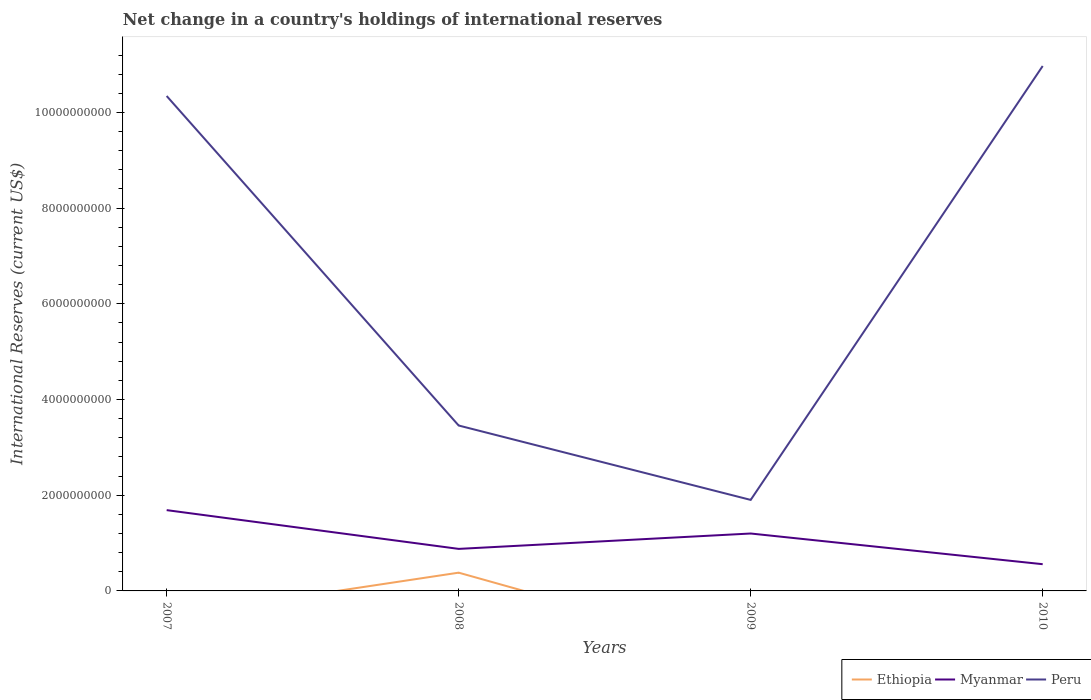Is the number of lines equal to the number of legend labels?
Give a very brief answer. No. Across all years, what is the maximum international reserves in Ethiopia?
Offer a terse response. 0. What is the total international reserves in Peru in the graph?
Make the answer very short. 6.89e+09. What is the difference between the highest and the second highest international reserves in Ethiopia?
Keep it short and to the point. 3.82e+08. What is the difference between the highest and the lowest international reserves in Myanmar?
Give a very brief answer. 2. Is the international reserves in Myanmar strictly greater than the international reserves in Peru over the years?
Give a very brief answer. Yes. How many lines are there?
Your response must be concise. 3. How many years are there in the graph?
Provide a succinct answer. 4. Are the values on the major ticks of Y-axis written in scientific E-notation?
Offer a very short reply. No. Does the graph contain any zero values?
Provide a short and direct response. Yes. Does the graph contain grids?
Make the answer very short. No. Where does the legend appear in the graph?
Your response must be concise. Bottom right. How many legend labels are there?
Offer a terse response. 3. What is the title of the graph?
Your answer should be compact. Net change in a country's holdings of international reserves. What is the label or title of the Y-axis?
Provide a short and direct response. International Reserves (current US$). What is the International Reserves (current US$) of Ethiopia in 2007?
Offer a terse response. 0. What is the International Reserves (current US$) of Myanmar in 2007?
Provide a succinct answer. 1.69e+09. What is the International Reserves (current US$) of Peru in 2007?
Give a very brief answer. 1.03e+1. What is the International Reserves (current US$) of Ethiopia in 2008?
Give a very brief answer. 3.82e+08. What is the International Reserves (current US$) in Myanmar in 2008?
Provide a succinct answer. 8.78e+08. What is the International Reserves (current US$) of Peru in 2008?
Provide a succinct answer. 3.46e+09. What is the International Reserves (current US$) in Ethiopia in 2009?
Provide a short and direct response. 0. What is the International Reserves (current US$) in Myanmar in 2009?
Ensure brevity in your answer.  1.20e+09. What is the International Reserves (current US$) of Peru in 2009?
Give a very brief answer. 1.90e+09. What is the International Reserves (current US$) of Ethiopia in 2010?
Your answer should be compact. 0. What is the International Reserves (current US$) in Myanmar in 2010?
Make the answer very short. 5.59e+08. What is the International Reserves (current US$) of Peru in 2010?
Make the answer very short. 1.10e+1. Across all years, what is the maximum International Reserves (current US$) in Ethiopia?
Your response must be concise. 3.82e+08. Across all years, what is the maximum International Reserves (current US$) of Myanmar?
Offer a terse response. 1.69e+09. Across all years, what is the maximum International Reserves (current US$) of Peru?
Make the answer very short. 1.10e+1. Across all years, what is the minimum International Reserves (current US$) of Myanmar?
Ensure brevity in your answer.  5.59e+08. Across all years, what is the minimum International Reserves (current US$) of Peru?
Offer a terse response. 1.90e+09. What is the total International Reserves (current US$) of Ethiopia in the graph?
Offer a terse response. 3.82e+08. What is the total International Reserves (current US$) of Myanmar in the graph?
Offer a very short reply. 4.33e+09. What is the total International Reserves (current US$) in Peru in the graph?
Your answer should be very brief. 2.67e+1. What is the difference between the International Reserves (current US$) in Myanmar in 2007 and that in 2008?
Make the answer very short. 8.10e+08. What is the difference between the International Reserves (current US$) in Peru in 2007 and that in 2008?
Offer a terse response. 6.89e+09. What is the difference between the International Reserves (current US$) in Myanmar in 2007 and that in 2009?
Ensure brevity in your answer.  4.88e+08. What is the difference between the International Reserves (current US$) of Peru in 2007 and that in 2009?
Your answer should be very brief. 8.44e+09. What is the difference between the International Reserves (current US$) of Myanmar in 2007 and that in 2010?
Make the answer very short. 1.13e+09. What is the difference between the International Reserves (current US$) of Peru in 2007 and that in 2010?
Your answer should be very brief. -6.27e+08. What is the difference between the International Reserves (current US$) in Myanmar in 2008 and that in 2009?
Your answer should be very brief. -3.21e+08. What is the difference between the International Reserves (current US$) in Peru in 2008 and that in 2009?
Provide a short and direct response. 1.55e+09. What is the difference between the International Reserves (current US$) in Myanmar in 2008 and that in 2010?
Make the answer very short. 3.20e+08. What is the difference between the International Reserves (current US$) of Peru in 2008 and that in 2010?
Your response must be concise. -7.51e+09. What is the difference between the International Reserves (current US$) of Myanmar in 2009 and that in 2010?
Offer a very short reply. 6.41e+08. What is the difference between the International Reserves (current US$) of Peru in 2009 and that in 2010?
Make the answer very short. -9.07e+09. What is the difference between the International Reserves (current US$) of Myanmar in 2007 and the International Reserves (current US$) of Peru in 2008?
Offer a very short reply. -1.77e+09. What is the difference between the International Reserves (current US$) of Myanmar in 2007 and the International Reserves (current US$) of Peru in 2009?
Your answer should be very brief. -2.14e+08. What is the difference between the International Reserves (current US$) of Myanmar in 2007 and the International Reserves (current US$) of Peru in 2010?
Keep it short and to the point. -9.28e+09. What is the difference between the International Reserves (current US$) of Ethiopia in 2008 and the International Reserves (current US$) of Myanmar in 2009?
Keep it short and to the point. -8.18e+08. What is the difference between the International Reserves (current US$) of Ethiopia in 2008 and the International Reserves (current US$) of Peru in 2009?
Your answer should be very brief. -1.52e+09. What is the difference between the International Reserves (current US$) of Myanmar in 2008 and the International Reserves (current US$) of Peru in 2009?
Give a very brief answer. -1.02e+09. What is the difference between the International Reserves (current US$) in Ethiopia in 2008 and the International Reserves (current US$) in Myanmar in 2010?
Provide a succinct answer. -1.77e+08. What is the difference between the International Reserves (current US$) of Ethiopia in 2008 and the International Reserves (current US$) of Peru in 2010?
Your answer should be compact. -1.06e+1. What is the difference between the International Reserves (current US$) in Myanmar in 2008 and the International Reserves (current US$) in Peru in 2010?
Your answer should be compact. -1.01e+1. What is the difference between the International Reserves (current US$) in Myanmar in 2009 and the International Reserves (current US$) in Peru in 2010?
Your response must be concise. -9.77e+09. What is the average International Reserves (current US$) of Ethiopia per year?
Offer a terse response. 9.54e+07. What is the average International Reserves (current US$) in Myanmar per year?
Give a very brief answer. 1.08e+09. What is the average International Reserves (current US$) of Peru per year?
Your response must be concise. 6.67e+09. In the year 2007, what is the difference between the International Reserves (current US$) of Myanmar and International Reserves (current US$) of Peru?
Give a very brief answer. -8.66e+09. In the year 2008, what is the difference between the International Reserves (current US$) in Ethiopia and International Reserves (current US$) in Myanmar?
Offer a terse response. -4.97e+08. In the year 2008, what is the difference between the International Reserves (current US$) of Ethiopia and International Reserves (current US$) of Peru?
Your answer should be compact. -3.08e+09. In the year 2008, what is the difference between the International Reserves (current US$) in Myanmar and International Reserves (current US$) in Peru?
Your response must be concise. -2.58e+09. In the year 2009, what is the difference between the International Reserves (current US$) of Myanmar and International Reserves (current US$) of Peru?
Offer a very short reply. -7.02e+08. In the year 2010, what is the difference between the International Reserves (current US$) in Myanmar and International Reserves (current US$) in Peru?
Your answer should be very brief. -1.04e+1. What is the ratio of the International Reserves (current US$) in Myanmar in 2007 to that in 2008?
Ensure brevity in your answer.  1.92. What is the ratio of the International Reserves (current US$) of Peru in 2007 to that in 2008?
Your response must be concise. 2.99. What is the ratio of the International Reserves (current US$) of Myanmar in 2007 to that in 2009?
Offer a terse response. 1.41. What is the ratio of the International Reserves (current US$) of Peru in 2007 to that in 2009?
Ensure brevity in your answer.  5.44. What is the ratio of the International Reserves (current US$) of Myanmar in 2007 to that in 2010?
Make the answer very short. 3.02. What is the ratio of the International Reserves (current US$) in Peru in 2007 to that in 2010?
Offer a terse response. 0.94. What is the ratio of the International Reserves (current US$) in Myanmar in 2008 to that in 2009?
Provide a succinct answer. 0.73. What is the ratio of the International Reserves (current US$) in Peru in 2008 to that in 2009?
Ensure brevity in your answer.  1.82. What is the ratio of the International Reserves (current US$) of Myanmar in 2008 to that in 2010?
Provide a short and direct response. 1.57. What is the ratio of the International Reserves (current US$) in Peru in 2008 to that in 2010?
Your answer should be compact. 0.32. What is the ratio of the International Reserves (current US$) in Myanmar in 2009 to that in 2010?
Your response must be concise. 2.15. What is the ratio of the International Reserves (current US$) of Peru in 2009 to that in 2010?
Offer a very short reply. 0.17. What is the difference between the highest and the second highest International Reserves (current US$) of Myanmar?
Keep it short and to the point. 4.88e+08. What is the difference between the highest and the second highest International Reserves (current US$) of Peru?
Make the answer very short. 6.27e+08. What is the difference between the highest and the lowest International Reserves (current US$) of Ethiopia?
Offer a terse response. 3.82e+08. What is the difference between the highest and the lowest International Reserves (current US$) in Myanmar?
Provide a succinct answer. 1.13e+09. What is the difference between the highest and the lowest International Reserves (current US$) in Peru?
Ensure brevity in your answer.  9.07e+09. 